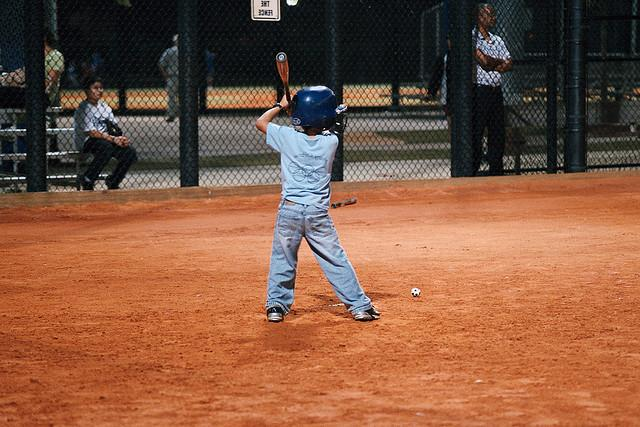What part of his uniform is he least likely to wear if he plays when he's older? jeans 